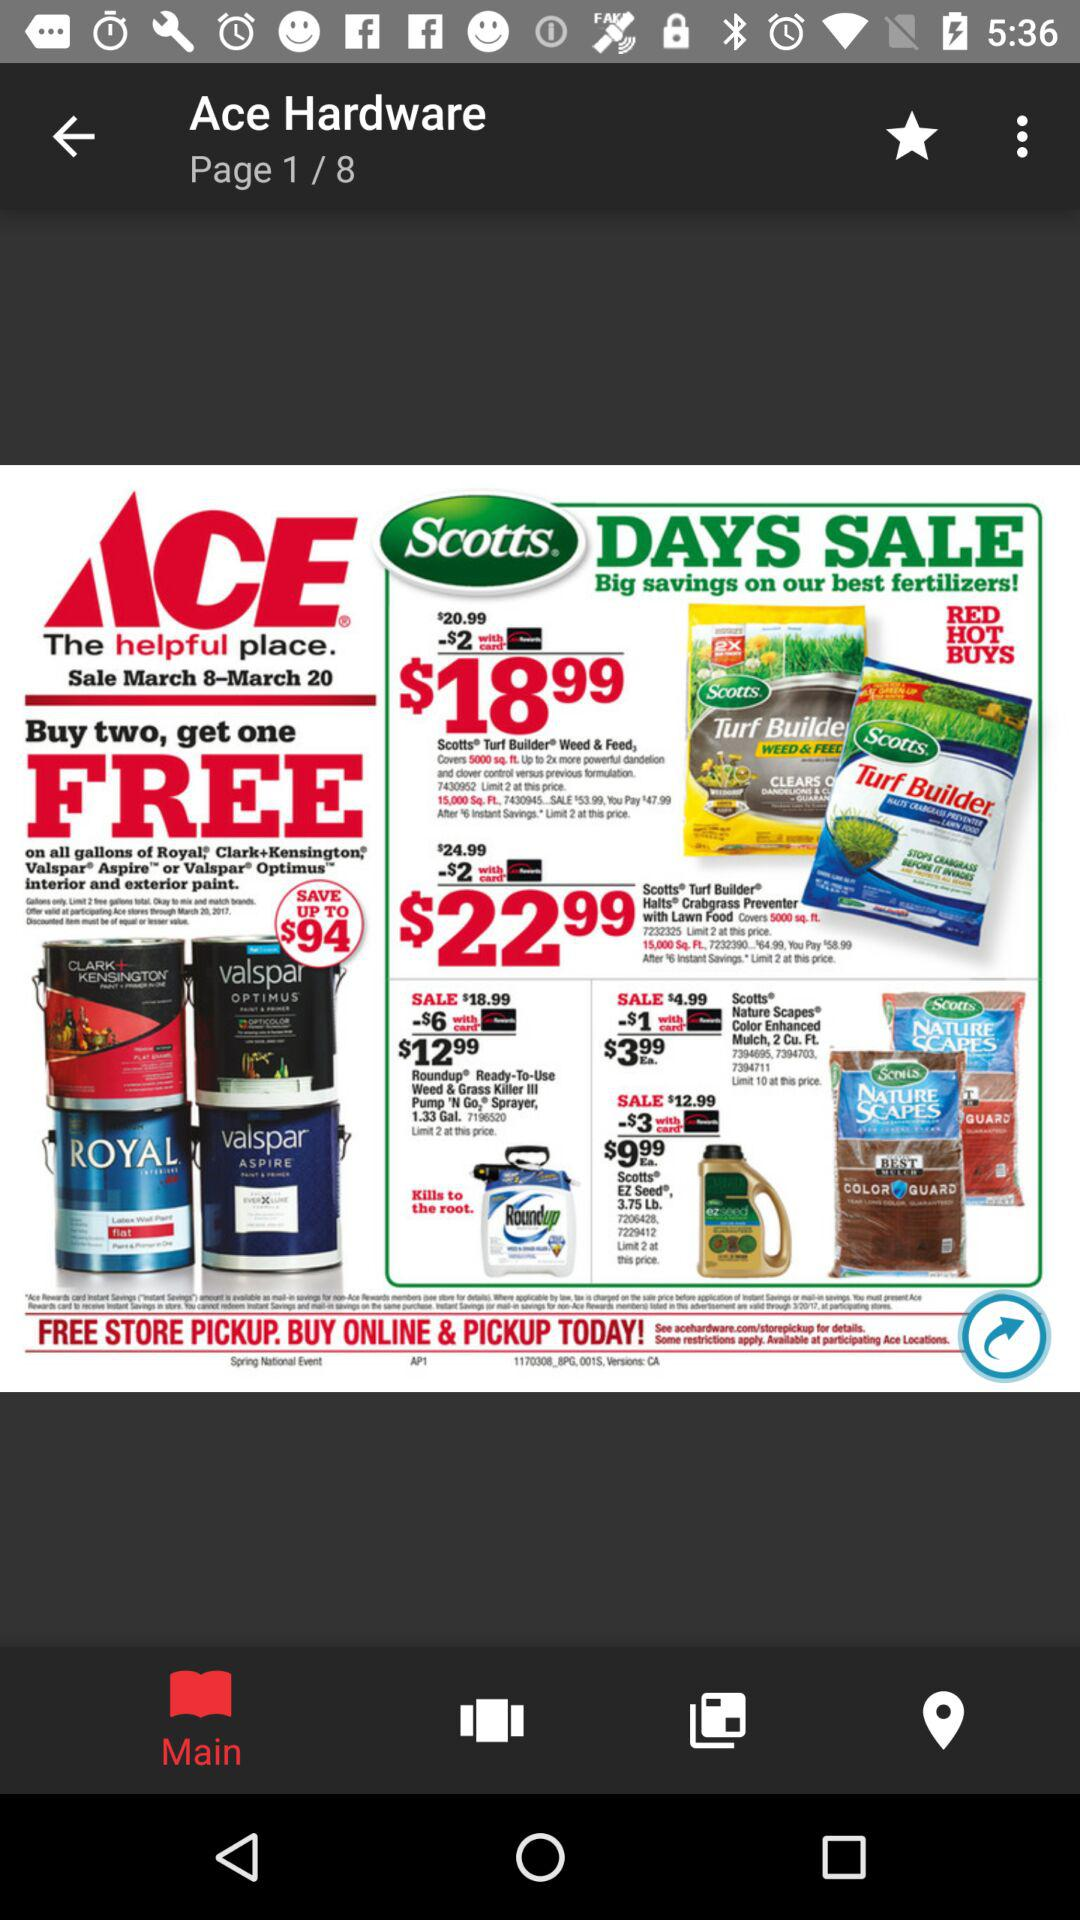What is the application name? The application name is "Ace Hardware". 